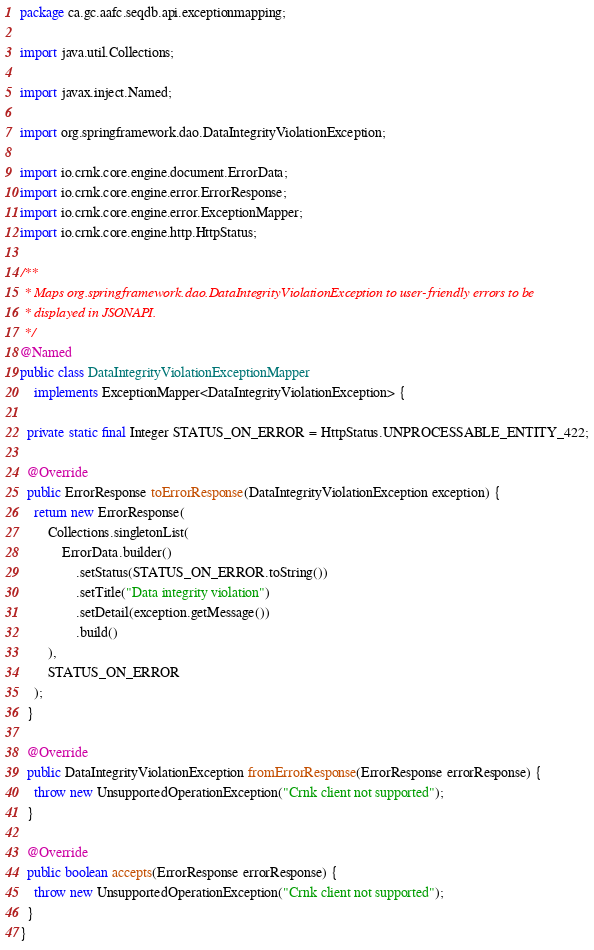<code> <loc_0><loc_0><loc_500><loc_500><_Java_>package ca.gc.aafc.seqdb.api.exceptionmapping;

import java.util.Collections;

import javax.inject.Named;

import org.springframework.dao.DataIntegrityViolationException;

import io.crnk.core.engine.document.ErrorData;
import io.crnk.core.engine.error.ErrorResponse;
import io.crnk.core.engine.error.ExceptionMapper;
import io.crnk.core.engine.http.HttpStatus;

/**
 * Maps org.springframework.dao.DataIntegrityViolationException to user-friendly errors to be
 * displayed in JSONAPI.
 */
@Named
public class DataIntegrityViolationExceptionMapper
    implements ExceptionMapper<DataIntegrityViolationException> {
  
  private static final Integer STATUS_ON_ERROR = HttpStatus.UNPROCESSABLE_ENTITY_422;

  @Override
  public ErrorResponse toErrorResponse(DataIntegrityViolationException exception) {
    return new ErrorResponse(
        Collections.singletonList(
            ErrorData.builder()
                .setStatus(STATUS_ON_ERROR.toString())
                .setTitle("Data integrity violation")
                .setDetail(exception.getMessage())
                .build()
        ),
        STATUS_ON_ERROR
    );
  }

  @Override
  public DataIntegrityViolationException fromErrorResponse(ErrorResponse errorResponse) {
    throw new UnsupportedOperationException("Crnk client not supported");
  }

  @Override
  public boolean accepts(ErrorResponse errorResponse) {
    throw new UnsupportedOperationException("Crnk client not supported");
  }
}
</code> 